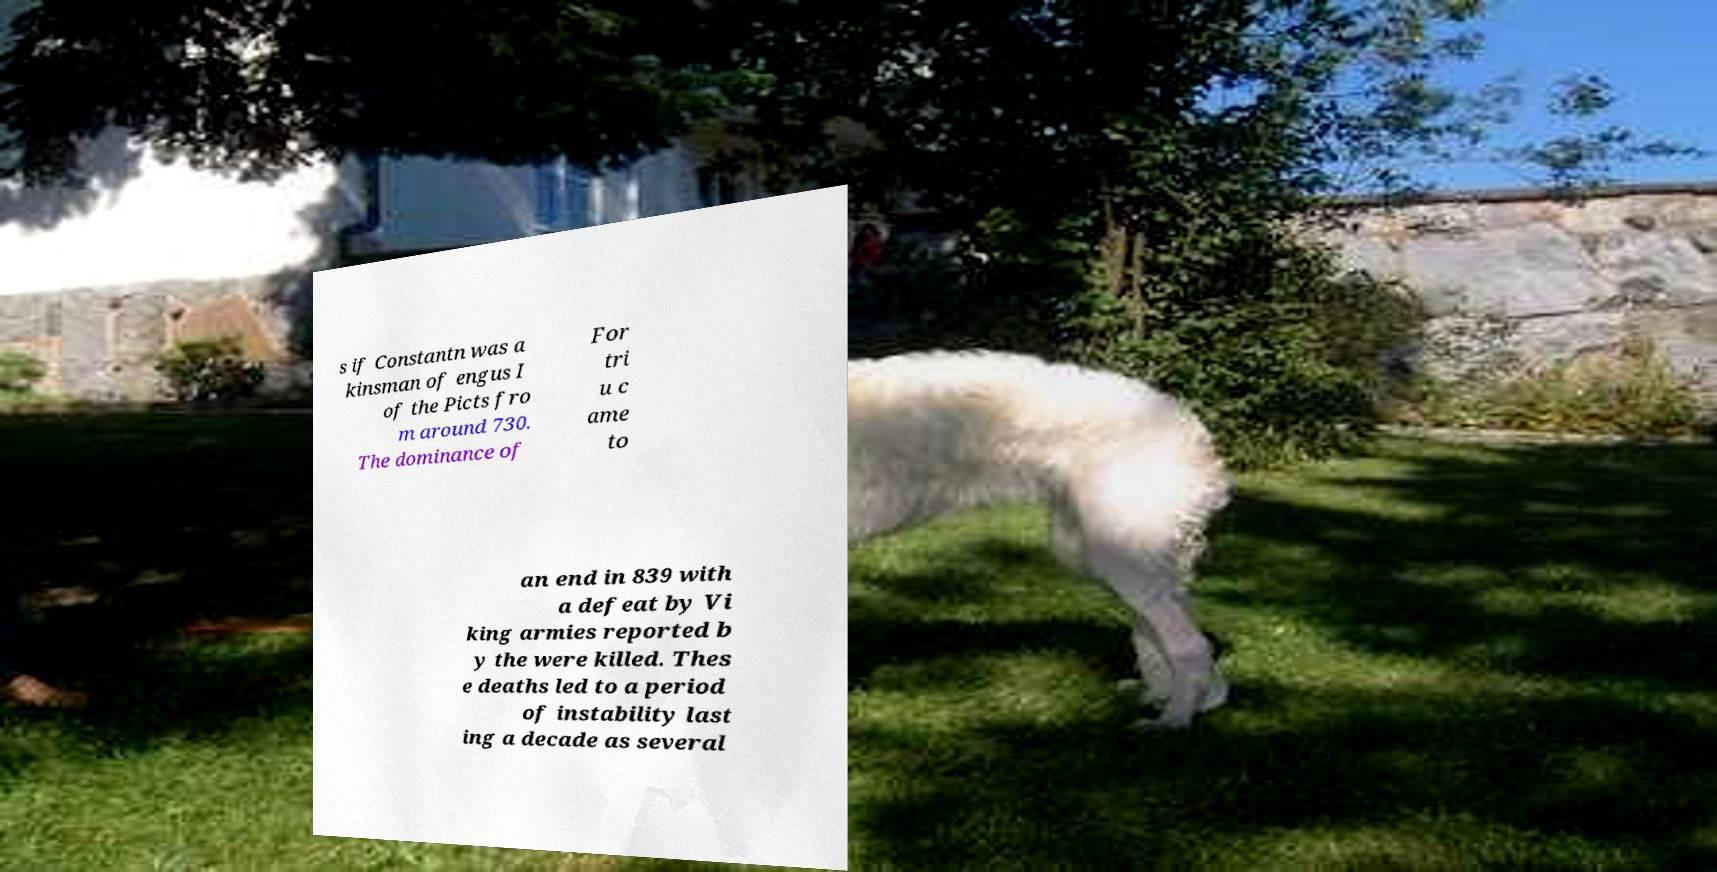There's text embedded in this image that I need extracted. Can you transcribe it verbatim? s if Constantn was a kinsman of engus I of the Picts fro m around 730. The dominance of For tri u c ame to an end in 839 with a defeat by Vi king armies reported b y the were killed. Thes e deaths led to a period of instability last ing a decade as several 